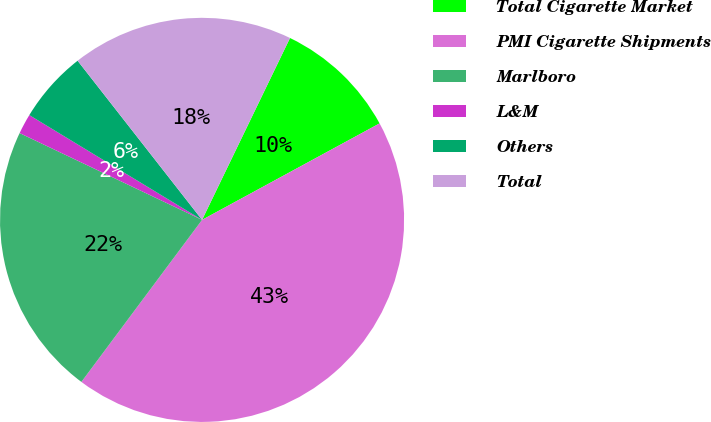Convert chart to OTSL. <chart><loc_0><loc_0><loc_500><loc_500><pie_chart><fcel>Total Cigarette Market<fcel>PMI Cigarette Shipments<fcel>Marlboro<fcel>L&M<fcel>Others<fcel>Total<nl><fcel>9.91%<fcel>43.11%<fcel>21.88%<fcel>1.61%<fcel>5.76%<fcel>17.73%<nl></chart> 